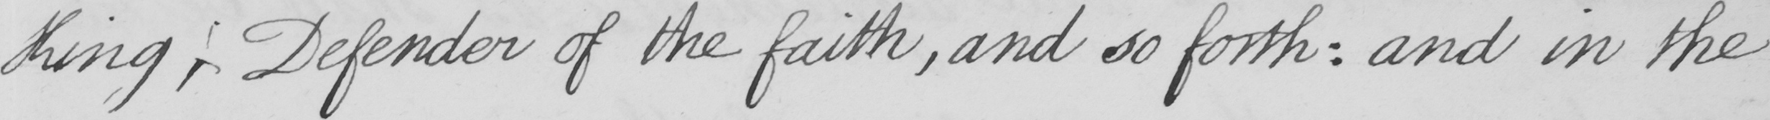Transcribe the text shown in this historical manuscript line. King , Defender of the faith , and so forth :  and in the 